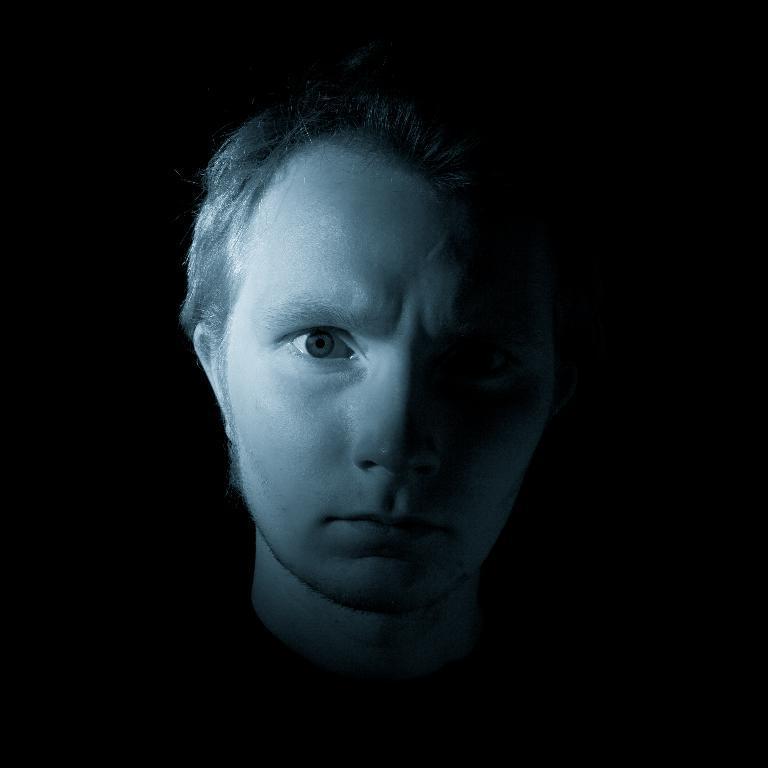Can you describe this image briefly? This picture shows a man and we see black background and we see light on his face. 